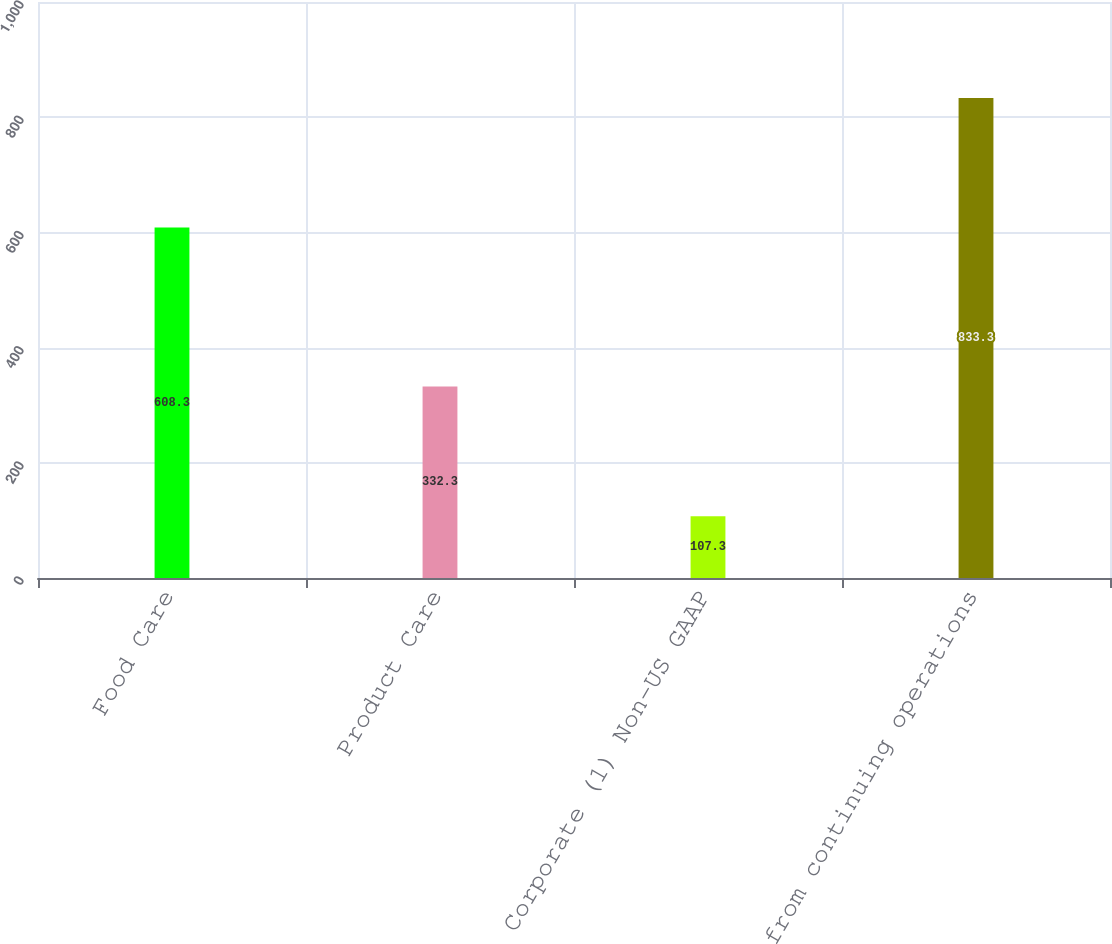Convert chart to OTSL. <chart><loc_0><loc_0><loc_500><loc_500><bar_chart><fcel>Food Care<fcel>Product Care<fcel>Corporate (1) Non-US GAAP<fcel>from continuing operations<nl><fcel>608.3<fcel>332.3<fcel>107.3<fcel>833.3<nl></chart> 